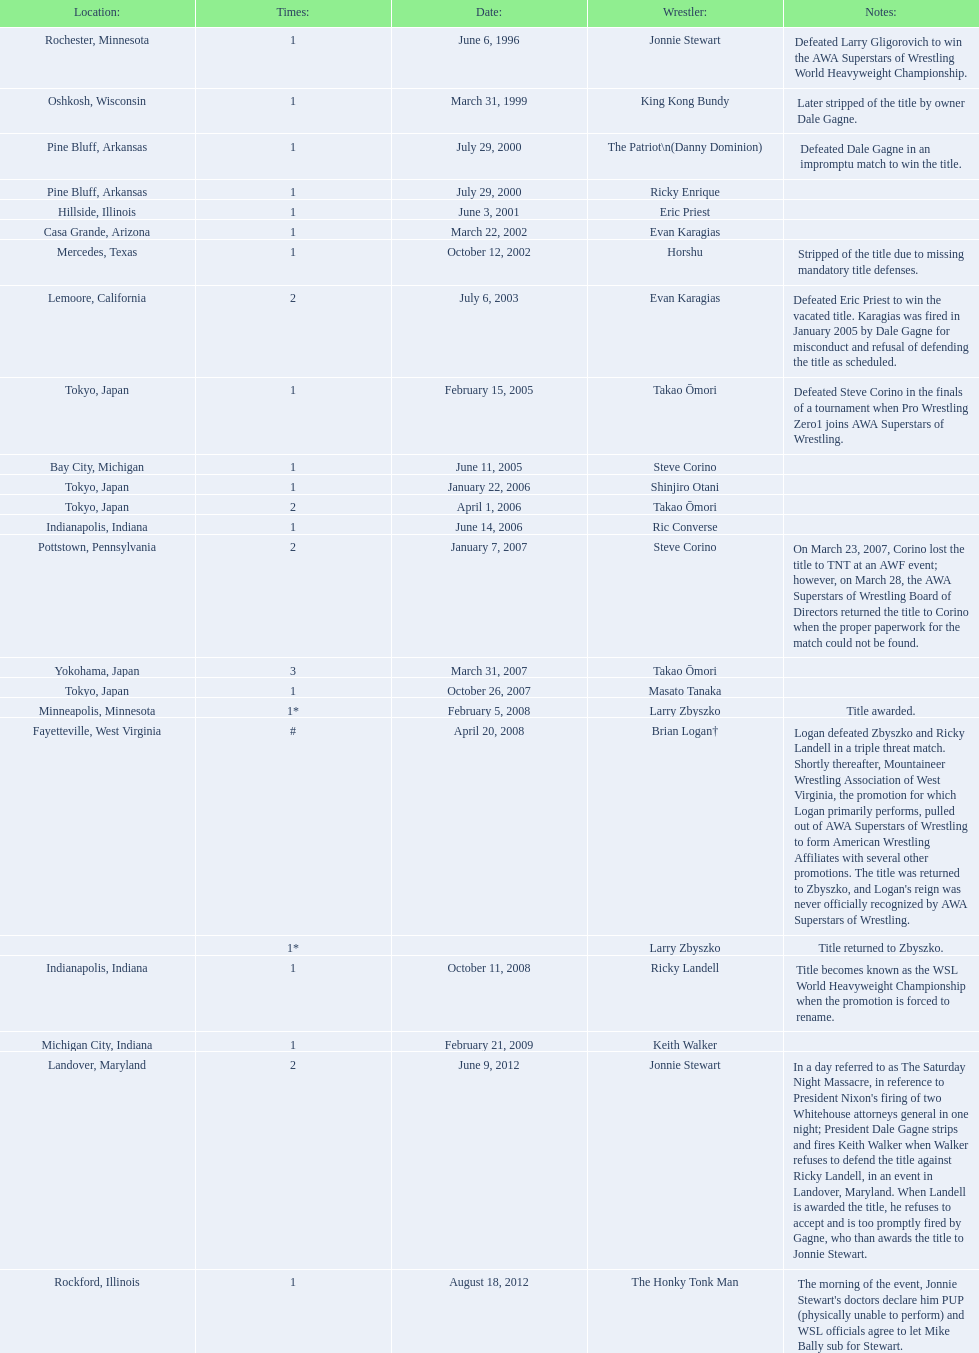Who are the wrestlers? Jonnie Stewart, Rochester, Minnesota, King Kong Bundy, Oshkosh, Wisconsin, The Patriot\n(Danny Dominion), Pine Bluff, Arkansas, Ricky Enrique, Pine Bluff, Arkansas, Eric Priest, Hillside, Illinois, Evan Karagias, Casa Grande, Arizona, Horshu, Mercedes, Texas, Evan Karagias, Lemoore, California, Takao Ōmori, Tokyo, Japan, Steve Corino, Bay City, Michigan, Shinjiro Otani, Tokyo, Japan, Takao Ōmori, Tokyo, Japan, Ric Converse, Indianapolis, Indiana, Steve Corino, Pottstown, Pennsylvania, Takao Ōmori, Yokohama, Japan, Masato Tanaka, Tokyo, Japan, Larry Zbyszko, Minneapolis, Minnesota, Brian Logan†, Fayetteville, West Virginia, Larry Zbyszko, , Ricky Landell, Indianapolis, Indiana, Keith Walker, Michigan City, Indiana, Jonnie Stewart, Landover, Maryland, The Honky Tonk Man, Rockford, Illinois. Who was from texas? Horshu, Mercedes, Texas. Who is he? Horshu. 